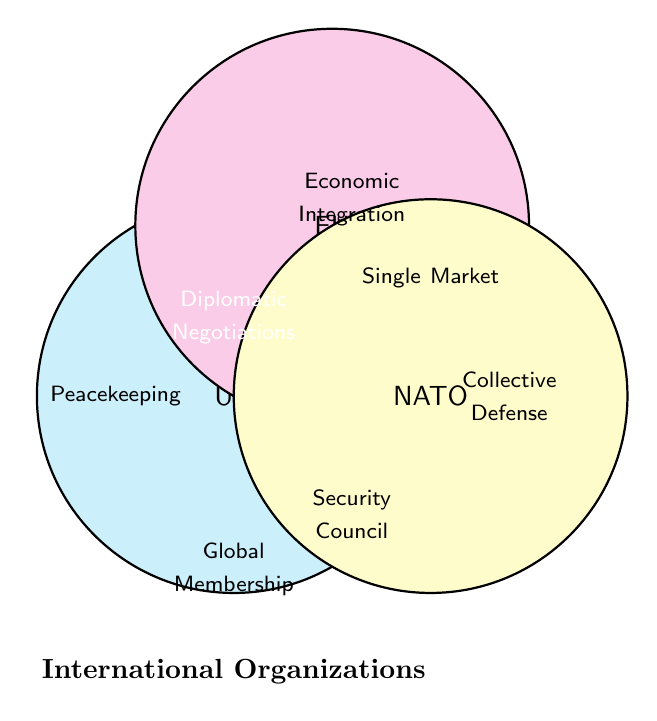What are the three organizations depicted in the Venn Diagram? The figure shows three colored circles, each labeled with the names of organizations. The three organizations are UN, EU, and NATO.
Answer: UN, EU, NATO Which organization is associated with "Security Council"? The term "Security Council" appears within the region labeled as UN, indicating it belongs to the UN.
Answer: UN What is the common feature located at the intersection of all three organizations? The term at the very center, where all three circles meet, indicates what is common to all three organizations. This term is "Diplomatic Negotiations".
Answer: Diplomatic Negotiations Which organization is linked to "Economic Integration"? The term "Economic Integration" is placed within the EU circle. Thus, it's associated with the EU.
Answer: EU What is the main focus of NATO according to the Venn Diagram? The term "Collective Defense" within the NATO circle points out the main focus of NATO.
Answer: Collective Defense How many unique terms are there for the UN exclusively? Count the terms that only appear in the UN's circle and not intersecting any other circle. There are three unique terms: "Peacekeeping," "Global Membership," and "Security Council".
Answer: 3 Which terms are shared between the UN and NATO but not with the EU? Look at the part of the Venn Diagram where UN and NATO circles overlap, excluding the EU circle. There are no terms listed in this specific section.
Answer: None Identify a term that suggests an educational program, and specify its organization. The term "Erasmus Program" is present within the EU circle, indicating it’s an educational program linked to the EU.
Answer: Erasmus Program, EU What is the distinguishing feature of the EU noted in the Venn Diagram? The term "Single Market" within the EU circle illustrates a key distinguishing feature of the EU.
Answer: Single Market Are there any terms related to healthcare or health organizations in the Venn Diagram? If so, which organization are they associated with? The term "WHO" is present, indicating a connection to healthcare. It is found within the UN circle, associating it with the UN.
Answer: WHO, UN 